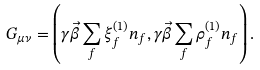Convert formula to latex. <formula><loc_0><loc_0><loc_500><loc_500>G _ { \mu \nu } = \left ( \gamma \vec { \beta } \sum _ { f } \xi _ { f } ^ { ( 1 ) } n _ { f } , \gamma \vec { \beta } \sum _ { f } \rho _ { f } ^ { ( 1 ) } n _ { f } \right ) .</formula> 